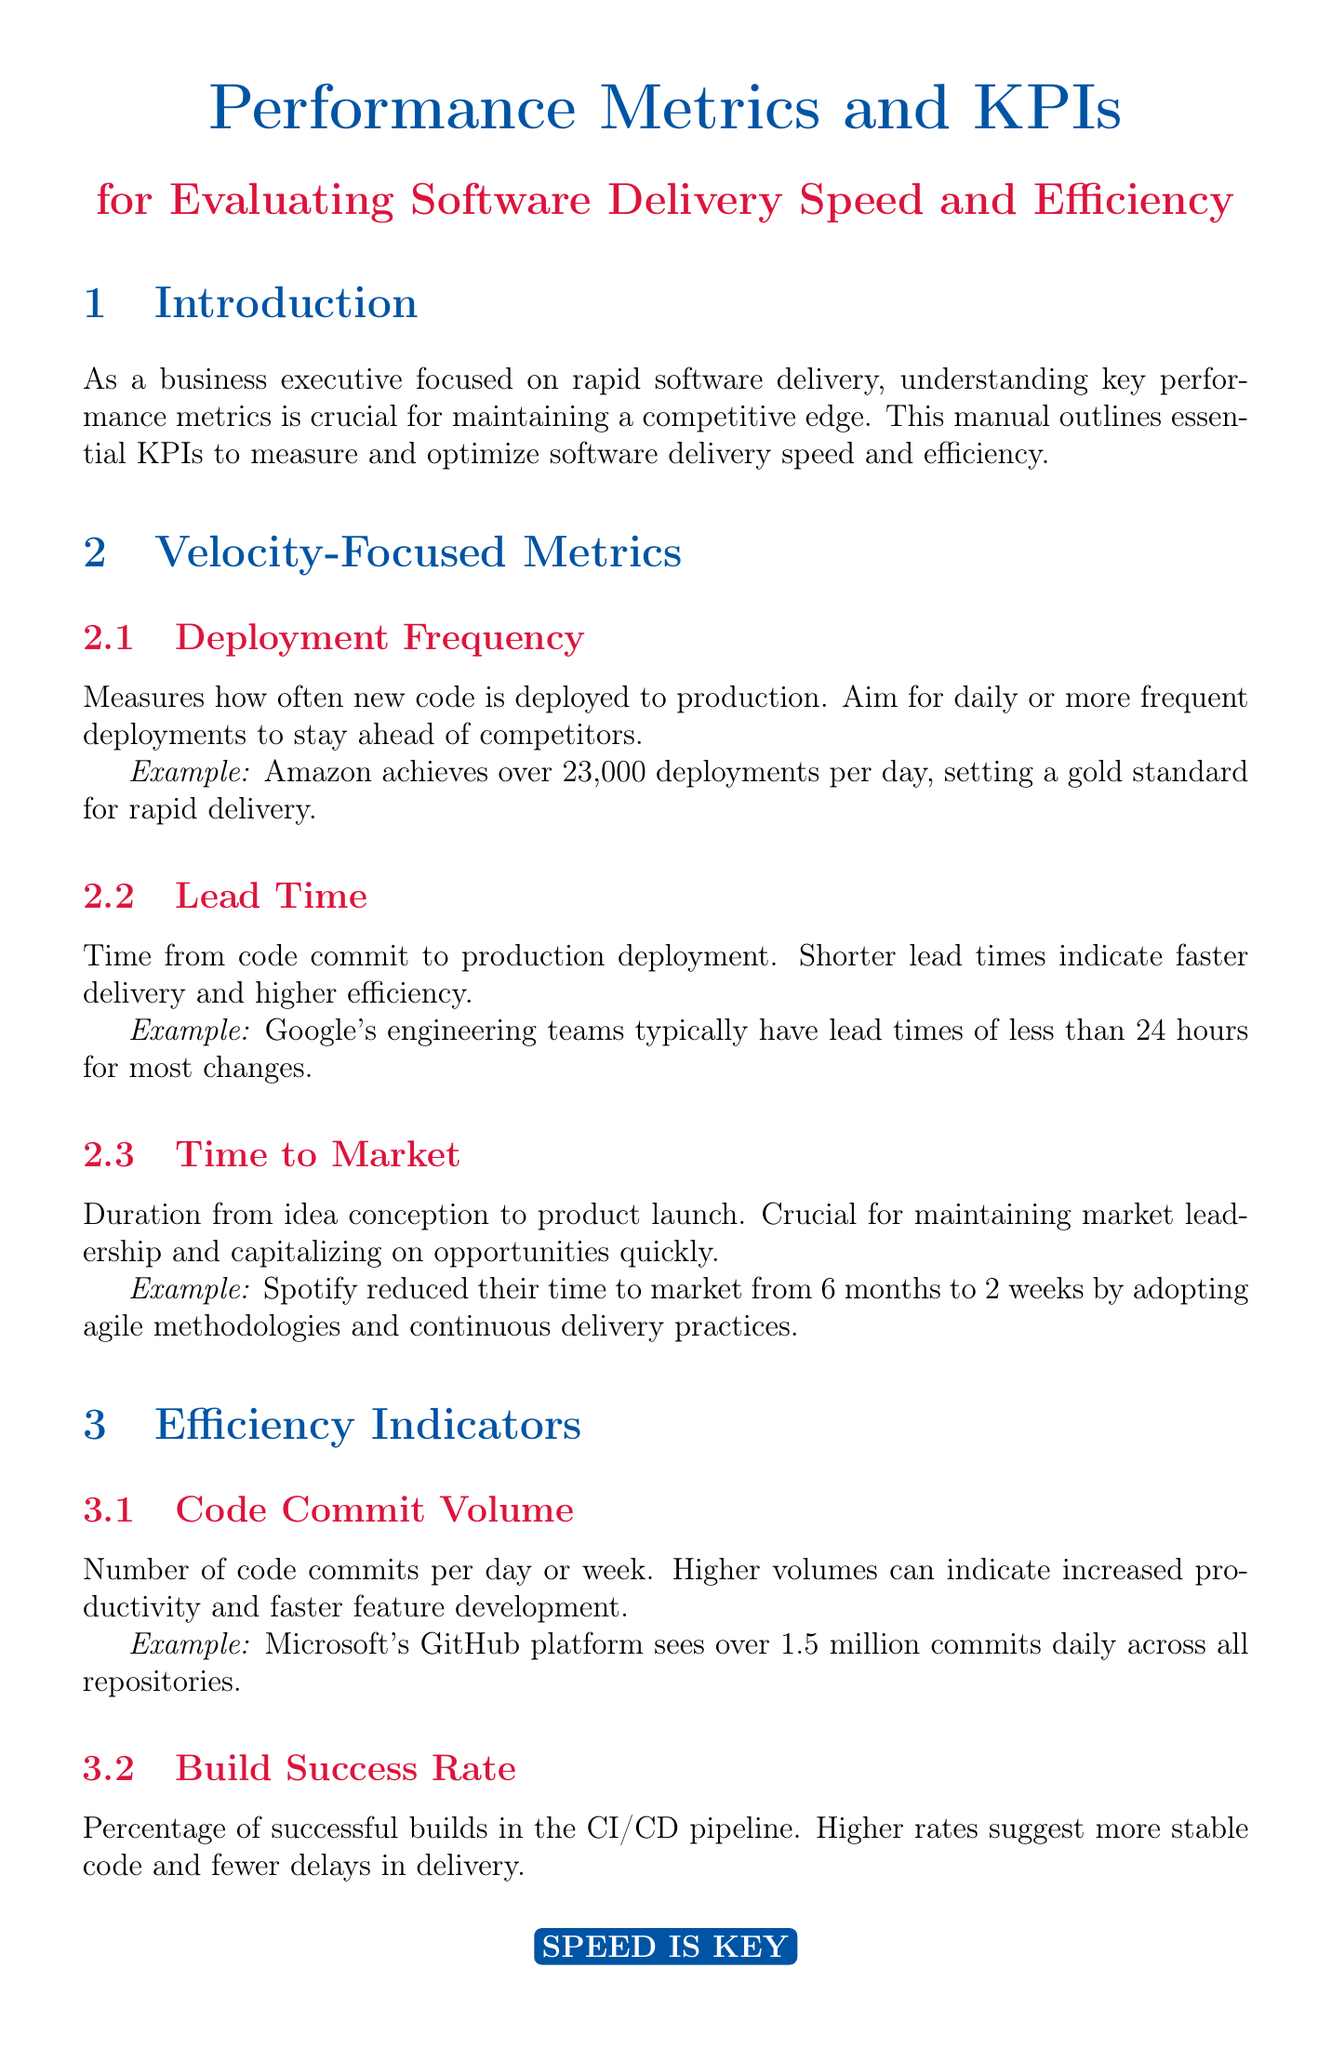What is the focus of the manual? The manual focuses on key performance metrics to measure and optimize software delivery speed and efficiency.
Answer: performance metrics How often should code be deployed to production? The recommended frequency for code deployment is daily or more frequent.
Answer: daily What is the example deployment frequency for Amazon? The document states that Amazon achieves over 23,000 deployments per day.
Answer: 23,000 deployments per day What is the ideal lead time from code commit to production? Shorter lead times indicate faster delivery, with Google's teams typically achieving lead times under 24 hours.
Answer: less than 24 hours What percentage of successful builds does Netflix maintain? The build success rate maintained by Netflix is over 99 percent.
Answer: over 99% Which tool is essential for maintaining high deployment frequency? Continuous integration tools are essential for maintaining high deployment frequency.
Answer: Continuous integration tools What metric indicates user satisfaction with the software? The Customer Satisfaction Score (CSAT) indicates user satisfaction.
Answer: Customer Satisfaction Score (CSAT) How much did Spotify reduce their time to market? Spotify reduced their time to market from 6 months to 2 weeks.
Answer: 6 months to 2 weeks What does revenue per deploy measure? Revenue per deploy measures the financial impact of each deployment.
Answer: financial impact 